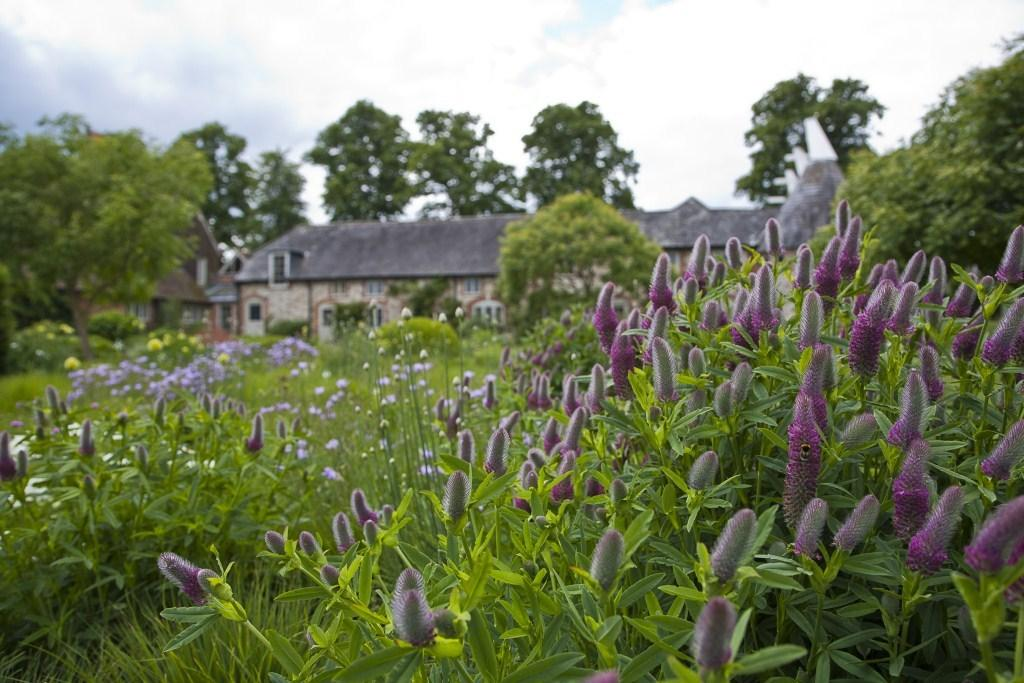What type of vegetation is present at the bottom of the image? There are plants at the bottom of the image. What specific features of the plants can be seen in the image? There are flowers, buds, and leaves visible in the image. What can be seen in the background of the image? There are trees, houseplants, the sky, and clouds visible in the background of the image. What type of love can be seen in the image? There is no love present in the image; it features plants, flowers, buds, leaves, trees, houseplants, the sky, and clouds. How does the image demand attention? The image does not demand attention; it is a visual representation of plants, flowers, buds, leaves, trees, houseplants, the sky, and clouds. 